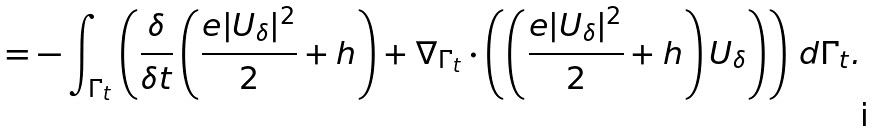Convert formula to latex. <formula><loc_0><loc_0><loc_500><loc_500>= - \int _ { \Gamma _ { t } } \left ( \frac { \delta } { \delta t } \left ( \frac { e | U _ { \delta } | ^ { 2 } } { 2 } + h \right ) + \nabla _ { \Gamma _ { t } } \cdot \left ( \left ( \frac { e | U _ { \delta } | ^ { 2 } } { 2 } + h \right ) U _ { \delta } \right ) \right ) \, d \Gamma _ { t } .</formula> 